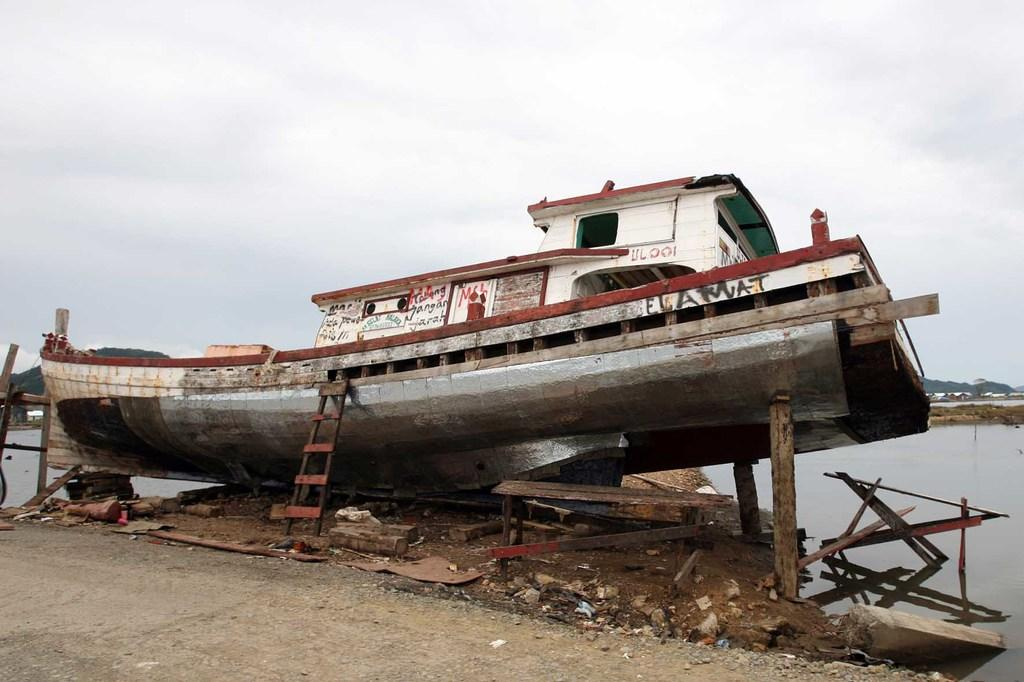What type of house is in the image? There is a wooden house in the image. What object is present that might be used for climbing or reaching higher places? There is a ladder in the image. What natural element can be seen in the image? Water is visible in the image. What is visible above the house and water? The sky is visible in the image. How many quarters can be seen on the roof of the wooden house in the image? There are no quarters visible on the roof of the wooden house in the image. 